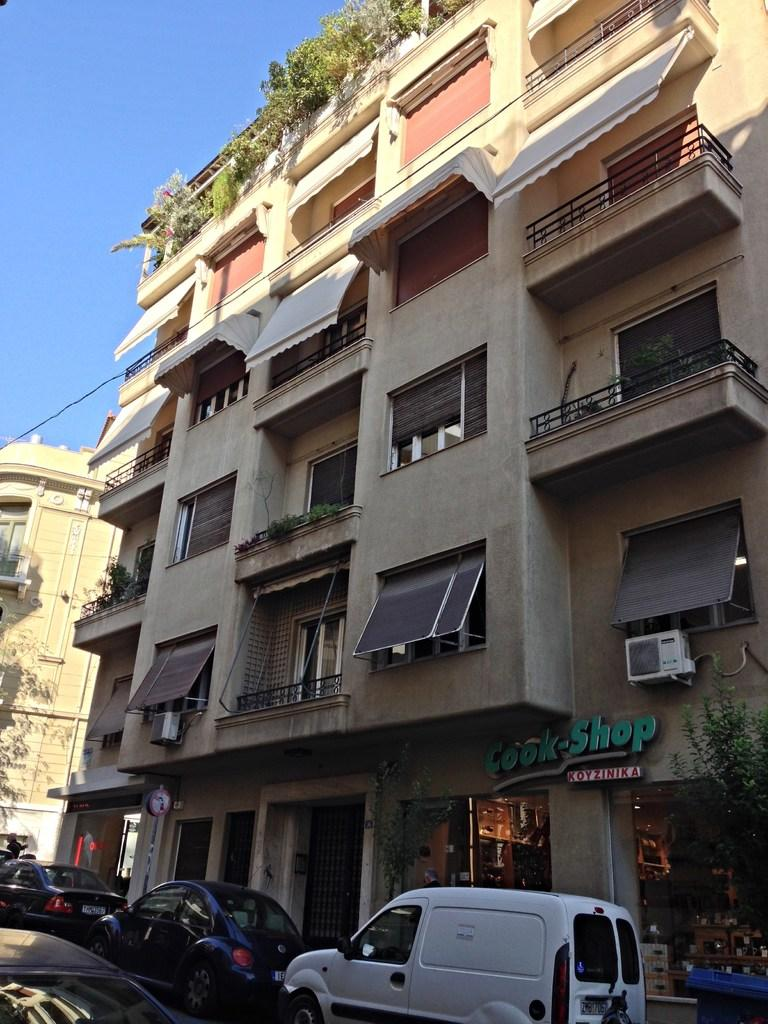What can be seen in the foreground of the image? There are vehicles in the foreground of the image. What type of structures are present in the image? There are buildings in the image. What other elements can be found in the image? There are plants in the image. What is visible at the top of the image? The sky is visible at the top of the image. How much tax is being paid for the vehicles in the image? There is no information about tax in the image, as it only shows vehicles, buildings, plants, and the sky. Can you tell me how many times the plants sneeze in the image? Plants do not sneeze, so this question cannot be answered based on the information provided. 